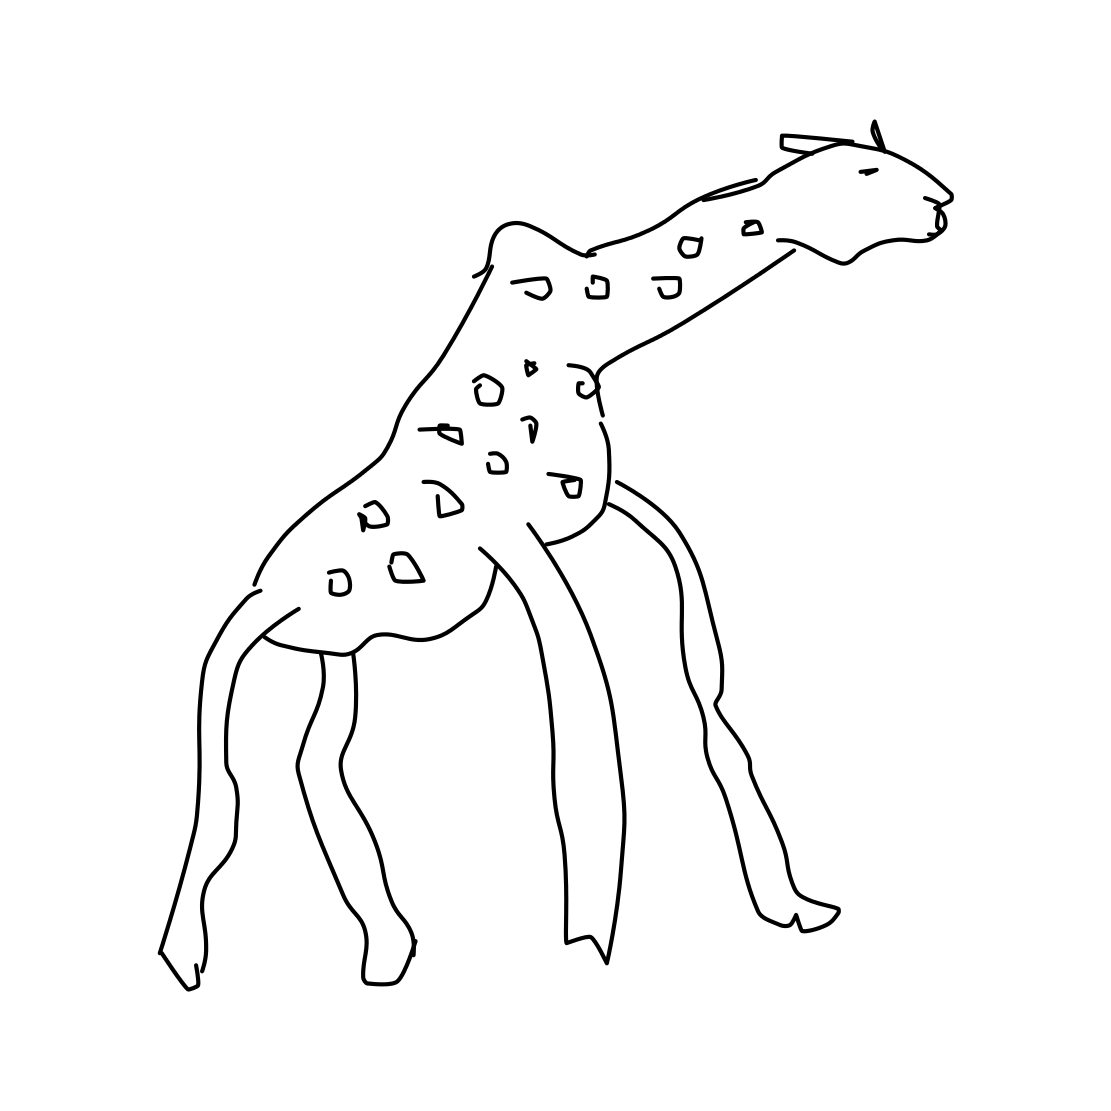Can you imagine this giraffe in a natural habitat? Certainly! This giraffe would be roaming the savanna of Africa, gracefully walking among the trees, and using its long neck to reach the high leaves that other herbivores can't. It's a serene scene, with the giraffe being an integral part of the ecosystem. 